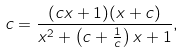Convert formula to latex. <formula><loc_0><loc_0><loc_500><loc_500>c = \frac { ( c x + 1 ) ( x + c ) } { x ^ { 2 } + \left ( c + \frac { 1 } { c } \right ) x + 1 } ,</formula> 